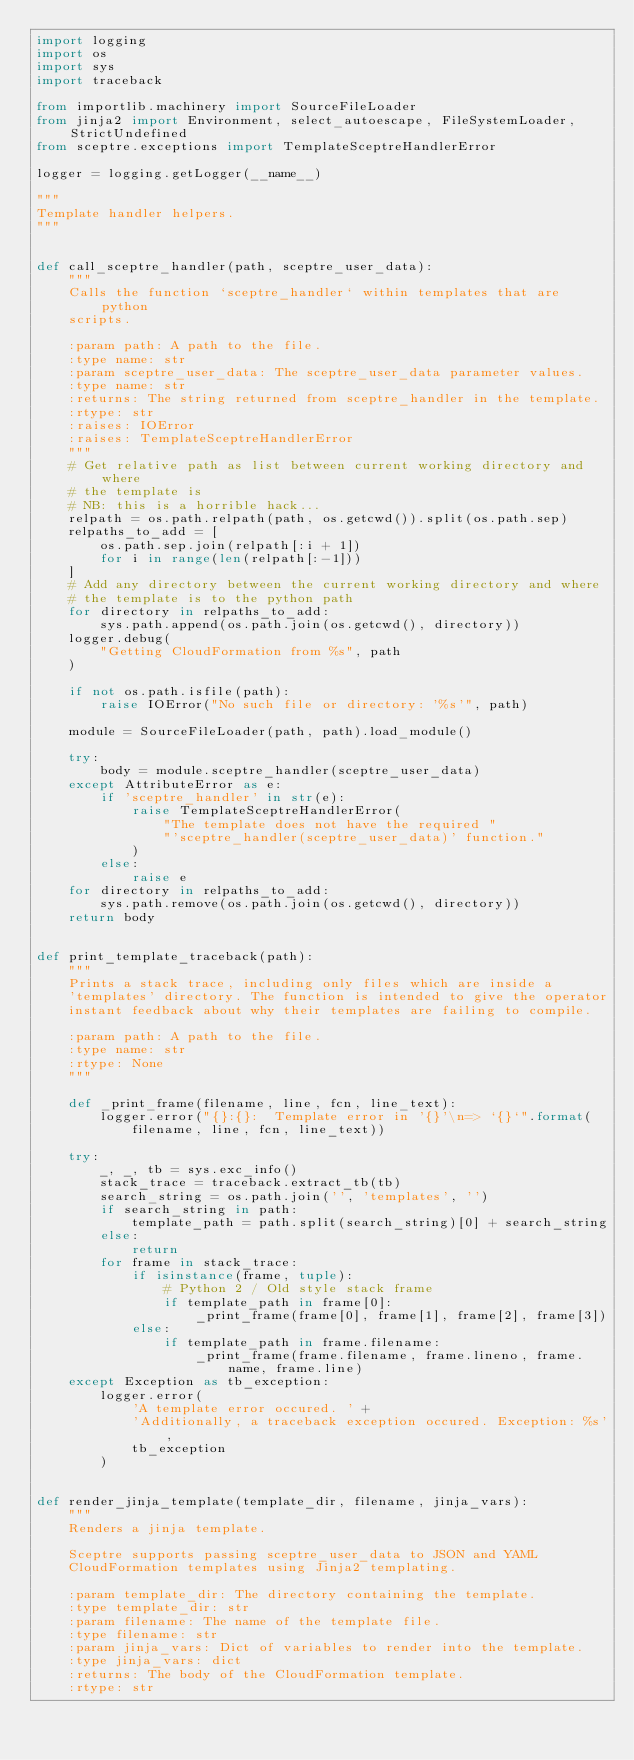Convert code to text. <code><loc_0><loc_0><loc_500><loc_500><_Python_>import logging
import os
import sys
import traceback

from importlib.machinery import SourceFileLoader
from jinja2 import Environment, select_autoescape, FileSystemLoader, StrictUndefined
from sceptre.exceptions import TemplateSceptreHandlerError

logger = logging.getLogger(__name__)

"""
Template handler helpers.
"""


def call_sceptre_handler(path, sceptre_user_data):
    """
    Calls the function `sceptre_handler` within templates that are python
    scripts.

    :param path: A path to the file.
    :type name: str
    :param sceptre_user_data: The sceptre_user_data parameter values.
    :type name: str
    :returns: The string returned from sceptre_handler in the template.
    :rtype: str
    :raises: IOError
    :raises: TemplateSceptreHandlerError
    """
    # Get relative path as list between current working directory and where
    # the template is
    # NB: this is a horrible hack...
    relpath = os.path.relpath(path, os.getcwd()).split(os.path.sep)
    relpaths_to_add = [
        os.path.sep.join(relpath[:i + 1])
        for i in range(len(relpath[:-1]))
    ]
    # Add any directory between the current working directory and where
    # the template is to the python path
    for directory in relpaths_to_add:
        sys.path.append(os.path.join(os.getcwd(), directory))
    logger.debug(
        "Getting CloudFormation from %s", path
    )

    if not os.path.isfile(path):
        raise IOError("No such file or directory: '%s'", path)

    module = SourceFileLoader(path, path).load_module()

    try:
        body = module.sceptre_handler(sceptre_user_data)
    except AttributeError as e:
        if 'sceptre_handler' in str(e):
            raise TemplateSceptreHandlerError(
                "The template does not have the required "
                "'sceptre_handler(sceptre_user_data)' function."
            )
        else:
            raise e
    for directory in relpaths_to_add:
        sys.path.remove(os.path.join(os.getcwd(), directory))
    return body


def print_template_traceback(path):
    """
    Prints a stack trace, including only files which are inside a
    'templates' directory. The function is intended to give the operator
    instant feedback about why their templates are failing to compile.

    :param path: A path to the file.
    :type name: str
    :rtype: None
    """

    def _print_frame(filename, line, fcn, line_text):
        logger.error("{}:{}:  Template error in '{}'\n=> `{}`".format(
            filename, line, fcn, line_text))

    try:
        _, _, tb = sys.exc_info()
        stack_trace = traceback.extract_tb(tb)
        search_string = os.path.join('', 'templates', '')
        if search_string in path:
            template_path = path.split(search_string)[0] + search_string
        else:
            return
        for frame in stack_trace:
            if isinstance(frame, tuple):
                # Python 2 / Old style stack frame
                if template_path in frame[0]:
                    _print_frame(frame[0], frame[1], frame[2], frame[3])
            else:
                if template_path in frame.filename:
                    _print_frame(frame.filename, frame.lineno, frame.name, frame.line)
    except Exception as tb_exception:
        logger.error(
            'A template error occured. ' +
            'Additionally, a traceback exception occured. Exception: %s',
            tb_exception
        )


def render_jinja_template(template_dir, filename, jinja_vars):
    """
    Renders a jinja template.

    Sceptre supports passing sceptre_user_data to JSON and YAML
    CloudFormation templates using Jinja2 templating.

    :param template_dir: The directory containing the template.
    :type template_dir: str
    :param filename: The name of the template file.
    :type filename: str
    :param jinja_vars: Dict of variables to render into the template.
    :type jinja_vars: dict
    :returns: The body of the CloudFormation template.
    :rtype: str</code> 